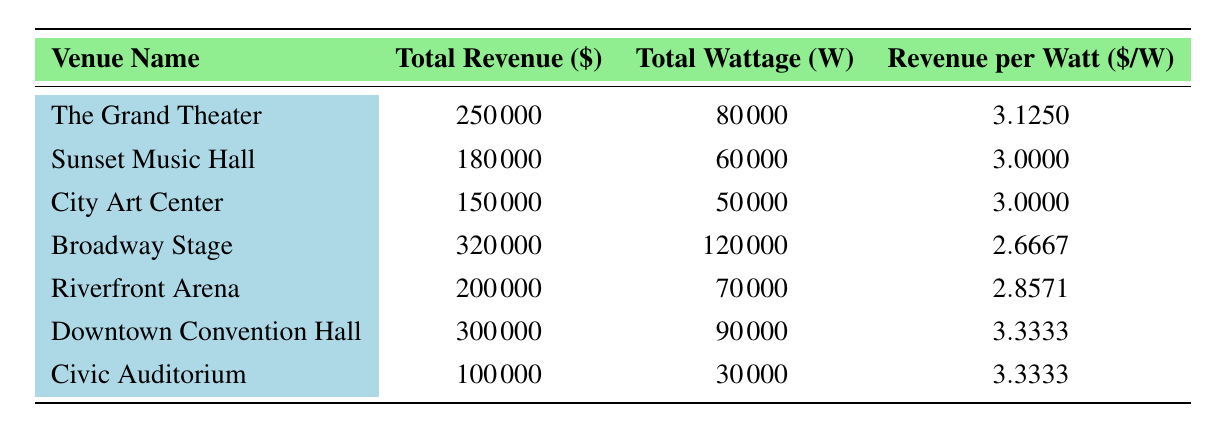What is the total revenue generated by the Downtown Convention Hall? The table shows that the total revenue for Downtown Convention Hall is listed directly under the "Total Revenue ($)" column. It is 300000.
Answer: 300000 Which venue has the highest revenue per watt? By comparing the "Revenue per Watt ($/W)" column, the value for Downtown Convention Hall is 3.3333, which is higher than any other venue listed.
Answer: Downtown Convention Hall How much total wattage is used by the Civic Auditorium? The table indicates that the Civic Auditorium has a total wattage of 30000, which can be found directly in the "Total Wattage (W)" column.
Answer: 30000 What is the revenue generated per watt for The Grand Theater, and how does it compare to the revenue per watt of Riverfront Arena? The revenue per watt for The Grand Theater is 3.1250, while for Riverfront Arena, it is 2.8571. Comparing these two values shows that The Grand Theater generates more revenue per watt.
Answer: The Grand Theater generates more revenue per watt If we sum the total revenues of Broadway Stage and City Art Center, what do we get? Adding the total revenue of Broadway Stage (320000) and City Art Center (150000) gives a sum of 470000.
Answer: 470000 Is the total revenue generated by Sunset Music Hall greater than that of the Civic Auditorium? Sunset Music Hall's total revenue is 180000, while Civic Auditorium's total revenue is 100000. Comparing these values shows that Sunset Music Hall has greater revenue.
Answer: Yes What is the average revenue per watt of all the venues combined? To find the average revenue per watt, we start by summing the revenue per watt of all venues (3.125 + 3.000 + 3.000 + 2.6667 + 2.8571 + 3.3333 + 3.3333 = 19.3154). Then we divide by the number of venues (7). So, the average is approximately 19.3154 / 7 = 2.7593.
Answer: 2.7593 Which venue has the lowest total wattage, and what is that wattage? By examining the "Total Wattage (W)" column, the Civic Auditorium shows the lowest wattage at 30000.
Answer: Civic Auditorium; 30000 Does City Art Center generate more revenue per watt than Broadway Stage? City Art Center has a revenue per watt of 3.0000, while Broadway Stage has 2.6667. Comparing these two values shows City Art Center generates more per watt.
Answer: Yes 